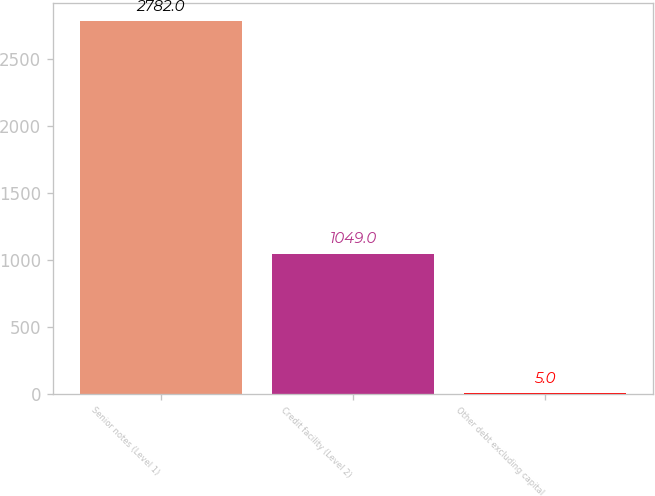Convert chart. <chart><loc_0><loc_0><loc_500><loc_500><bar_chart><fcel>Senior notes (Level 1)<fcel>Credit facility (Level 2)<fcel>Other debt excluding capital<nl><fcel>2782<fcel>1049<fcel>5<nl></chart> 